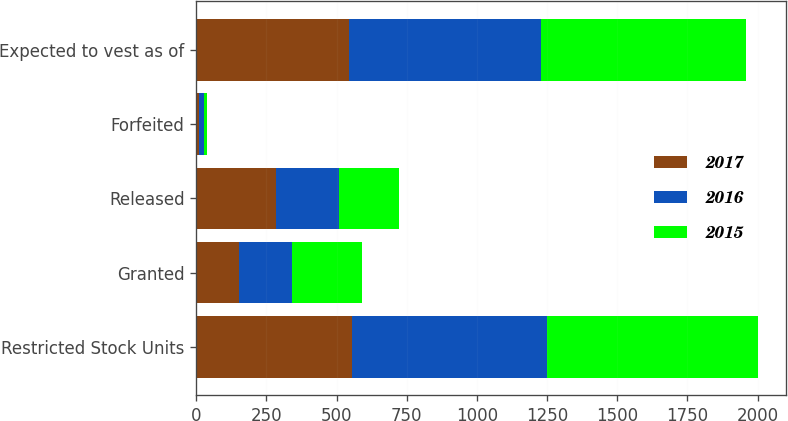Convert chart to OTSL. <chart><loc_0><loc_0><loc_500><loc_500><stacked_bar_chart><ecel><fcel>Restricted Stock Units<fcel>Granted<fcel>Released<fcel>Forfeited<fcel>Expected to vest as of<nl><fcel>2017<fcel>555<fcel>154<fcel>284<fcel>10<fcel>546<nl><fcel>2016<fcel>695<fcel>187<fcel>226<fcel>16<fcel>682<nl><fcel>2015<fcel>750<fcel>248<fcel>212<fcel>11<fcel>731<nl></chart> 